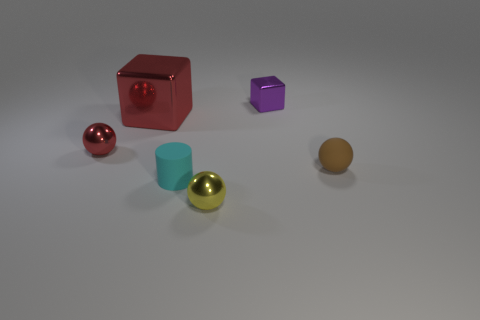Subtract 1 spheres. How many spheres are left? 2 Subtract all metal balls. How many balls are left? 1 Add 1 red shiny blocks. How many objects exist? 7 Subtract all purple balls. Subtract all purple blocks. How many balls are left? 3 Add 5 large red things. How many large red things exist? 6 Subtract 1 yellow spheres. How many objects are left? 5 Subtract all cylinders. How many objects are left? 5 Subtract all shiny cubes. Subtract all tiny yellow spheres. How many objects are left? 3 Add 6 yellow spheres. How many yellow spheres are left? 7 